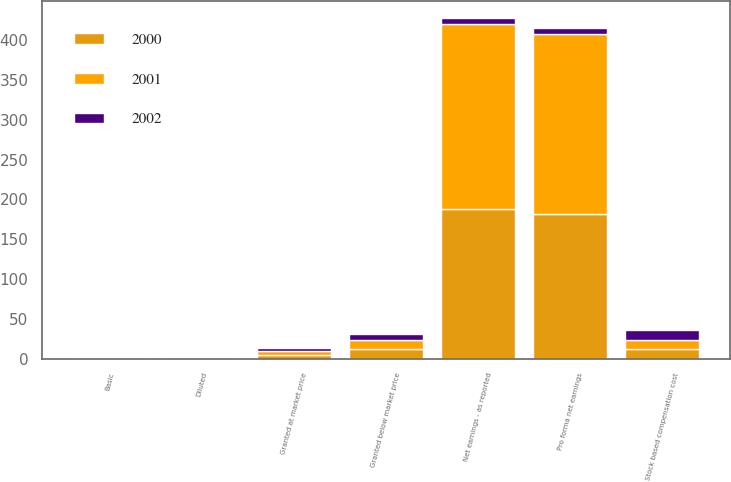Convert chart. <chart><loc_0><loc_0><loc_500><loc_500><stacked_bar_chart><ecel><fcel>Net earnings - as reported<fcel>Basic<fcel>Diluted<fcel>Stock based compensation cost<fcel>Pro forma net earnings<fcel>Granted at market price<fcel>Granted below market price<nl><fcel>2001<fcel>233.1<fcel>1.17<fcel>1.17<fcel>11.1<fcel>226.9<fcel>4.92<fcel>11.53<nl><fcel>2000<fcel>187.6<fcel>0.94<fcel>0.94<fcel>12.4<fcel>181.1<fcel>4.2<fcel>11.7<nl><fcel>2002<fcel>6.5<fcel>1.33<fcel>1.32<fcel>12.1<fcel>6.5<fcel>4.48<fcel>8.05<nl></chart> 